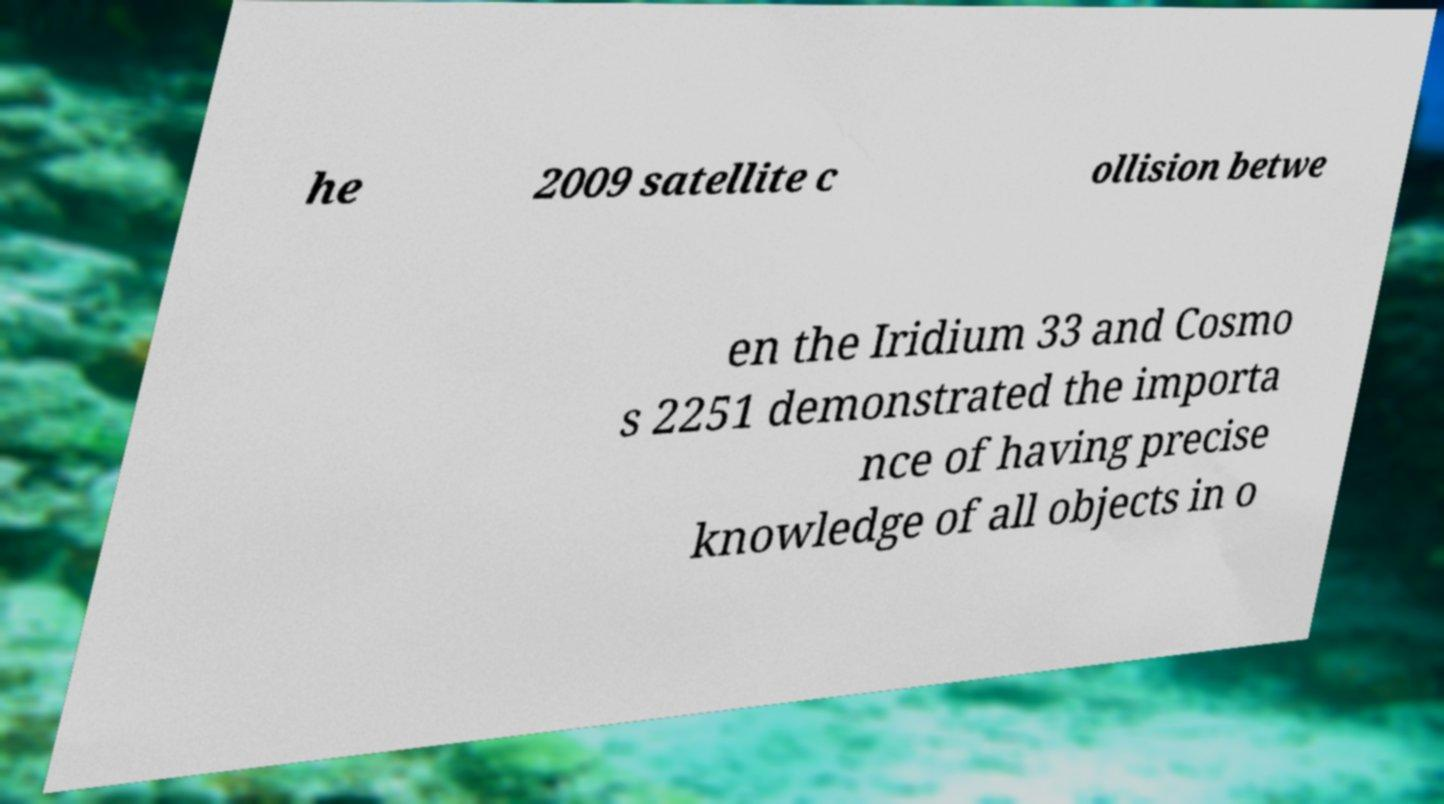Could you assist in decoding the text presented in this image and type it out clearly? he 2009 satellite c ollision betwe en the Iridium 33 and Cosmo s 2251 demonstrated the importa nce of having precise knowledge of all objects in o 